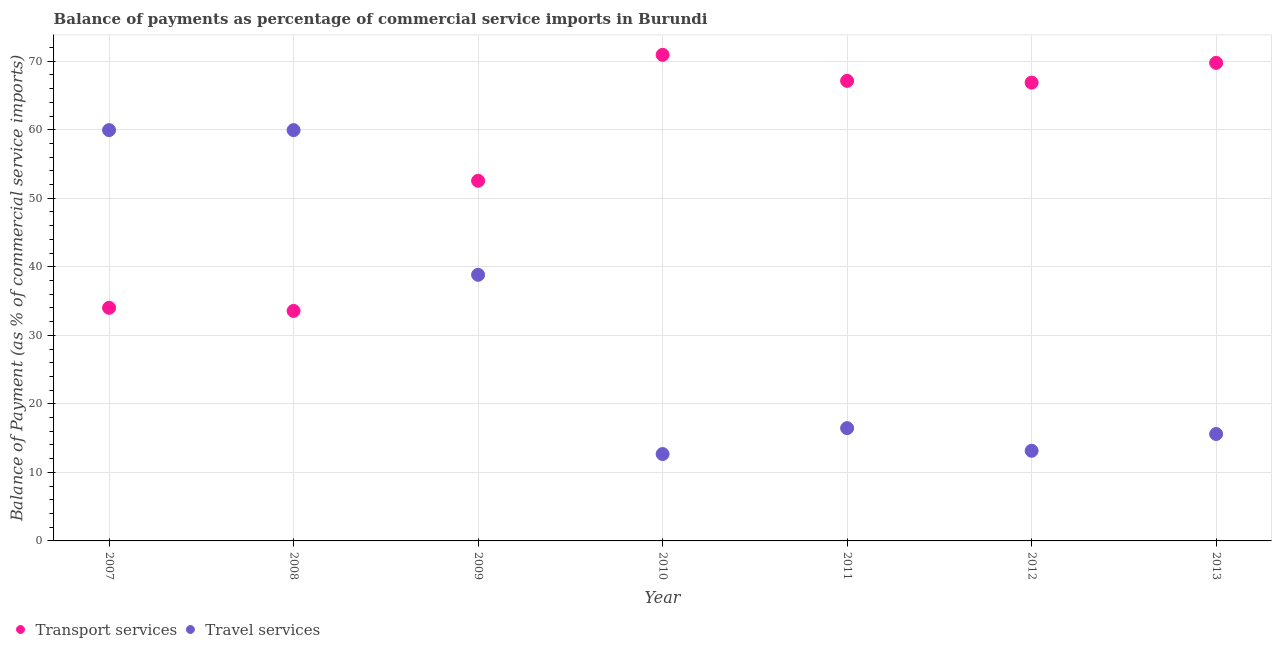How many different coloured dotlines are there?
Your response must be concise. 2. Is the number of dotlines equal to the number of legend labels?
Your answer should be compact. Yes. What is the balance of payments of transport services in 2013?
Ensure brevity in your answer.  69.76. Across all years, what is the maximum balance of payments of travel services?
Keep it short and to the point. 59.95. Across all years, what is the minimum balance of payments of transport services?
Make the answer very short. 33.56. In which year was the balance of payments of travel services maximum?
Keep it short and to the point. 2007. In which year was the balance of payments of transport services minimum?
Your answer should be very brief. 2008. What is the total balance of payments of travel services in the graph?
Your answer should be compact. 216.62. What is the difference between the balance of payments of travel services in 2007 and that in 2010?
Ensure brevity in your answer.  47.27. What is the difference between the balance of payments of travel services in 2007 and the balance of payments of transport services in 2013?
Give a very brief answer. -9.81. What is the average balance of payments of travel services per year?
Your answer should be compact. 30.95. In the year 2009, what is the difference between the balance of payments of transport services and balance of payments of travel services?
Provide a short and direct response. 13.72. In how many years, is the balance of payments of transport services greater than 8 %?
Make the answer very short. 7. What is the ratio of the balance of payments of travel services in 2007 to that in 2009?
Your answer should be very brief. 1.54. What is the difference between the highest and the second highest balance of payments of transport services?
Give a very brief answer. 1.17. What is the difference between the highest and the lowest balance of payments of transport services?
Keep it short and to the point. 37.37. Is the balance of payments of transport services strictly greater than the balance of payments of travel services over the years?
Ensure brevity in your answer.  No. How many years are there in the graph?
Provide a succinct answer. 7. Does the graph contain any zero values?
Give a very brief answer. No. What is the title of the graph?
Offer a very short reply. Balance of payments as percentage of commercial service imports in Burundi. What is the label or title of the Y-axis?
Offer a terse response. Balance of Payment (as % of commercial service imports). What is the Balance of Payment (as % of commercial service imports) in Transport services in 2007?
Offer a terse response. 34.02. What is the Balance of Payment (as % of commercial service imports) of Travel services in 2007?
Make the answer very short. 59.95. What is the Balance of Payment (as % of commercial service imports) in Transport services in 2008?
Offer a terse response. 33.56. What is the Balance of Payment (as % of commercial service imports) of Travel services in 2008?
Ensure brevity in your answer.  59.94. What is the Balance of Payment (as % of commercial service imports) in Transport services in 2009?
Offer a terse response. 52.56. What is the Balance of Payment (as % of commercial service imports) of Travel services in 2009?
Keep it short and to the point. 38.83. What is the Balance of Payment (as % of commercial service imports) in Transport services in 2010?
Give a very brief answer. 70.93. What is the Balance of Payment (as % of commercial service imports) of Travel services in 2010?
Offer a very short reply. 12.68. What is the Balance of Payment (as % of commercial service imports) in Transport services in 2011?
Provide a succinct answer. 67.13. What is the Balance of Payment (as % of commercial service imports) in Travel services in 2011?
Provide a short and direct response. 16.46. What is the Balance of Payment (as % of commercial service imports) in Transport services in 2012?
Make the answer very short. 66.88. What is the Balance of Payment (as % of commercial service imports) in Travel services in 2012?
Offer a very short reply. 13.16. What is the Balance of Payment (as % of commercial service imports) of Transport services in 2013?
Offer a very short reply. 69.76. What is the Balance of Payment (as % of commercial service imports) of Travel services in 2013?
Give a very brief answer. 15.6. Across all years, what is the maximum Balance of Payment (as % of commercial service imports) of Transport services?
Keep it short and to the point. 70.93. Across all years, what is the maximum Balance of Payment (as % of commercial service imports) in Travel services?
Offer a very short reply. 59.95. Across all years, what is the minimum Balance of Payment (as % of commercial service imports) in Transport services?
Make the answer very short. 33.56. Across all years, what is the minimum Balance of Payment (as % of commercial service imports) in Travel services?
Your answer should be very brief. 12.68. What is the total Balance of Payment (as % of commercial service imports) in Transport services in the graph?
Give a very brief answer. 394.84. What is the total Balance of Payment (as % of commercial service imports) in Travel services in the graph?
Provide a short and direct response. 216.62. What is the difference between the Balance of Payment (as % of commercial service imports) in Transport services in 2007 and that in 2008?
Provide a succinct answer. 0.46. What is the difference between the Balance of Payment (as % of commercial service imports) in Travel services in 2007 and that in 2008?
Provide a short and direct response. 0. What is the difference between the Balance of Payment (as % of commercial service imports) in Transport services in 2007 and that in 2009?
Offer a terse response. -18.54. What is the difference between the Balance of Payment (as % of commercial service imports) of Travel services in 2007 and that in 2009?
Provide a short and direct response. 21.11. What is the difference between the Balance of Payment (as % of commercial service imports) in Transport services in 2007 and that in 2010?
Make the answer very short. -36.91. What is the difference between the Balance of Payment (as % of commercial service imports) in Travel services in 2007 and that in 2010?
Your answer should be compact. 47.27. What is the difference between the Balance of Payment (as % of commercial service imports) of Transport services in 2007 and that in 2011?
Provide a succinct answer. -33.11. What is the difference between the Balance of Payment (as % of commercial service imports) in Travel services in 2007 and that in 2011?
Your answer should be very brief. 43.49. What is the difference between the Balance of Payment (as % of commercial service imports) in Transport services in 2007 and that in 2012?
Keep it short and to the point. -32.86. What is the difference between the Balance of Payment (as % of commercial service imports) of Travel services in 2007 and that in 2012?
Your answer should be compact. 46.79. What is the difference between the Balance of Payment (as % of commercial service imports) of Transport services in 2007 and that in 2013?
Make the answer very short. -35.74. What is the difference between the Balance of Payment (as % of commercial service imports) of Travel services in 2007 and that in 2013?
Your answer should be compact. 44.34. What is the difference between the Balance of Payment (as % of commercial service imports) in Transport services in 2008 and that in 2009?
Offer a very short reply. -18.99. What is the difference between the Balance of Payment (as % of commercial service imports) in Travel services in 2008 and that in 2009?
Keep it short and to the point. 21.11. What is the difference between the Balance of Payment (as % of commercial service imports) in Transport services in 2008 and that in 2010?
Keep it short and to the point. -37.37. What is the difference between the Balance of Payment (as % of commercial service imports) of Travel services in 2008 and that in 2010?
Give a very brief answer. 47.27. What is the difference between the Balance of Payment (as % of commercial service imports) in Transport services in 2008 and that in 2011?
Offer a very short reply. -33.57. What is the difference between the Balance of Payment (as % of commercial service imports) in Travel services in 2008 and that in 2011?
Make the answer very short. 43.49. What is the difference between the Balance of Payment (as % of commercial service imports) of Transport services in 2008 and that in 2012?
Your answer should be very brief. -33.32. What is the difference between the Balance of Payment (as % of commercial service imports) in Travel services in 2008 and that in 2012?
Your response must be concise. 46.79. What is the difference between the Balance of Payment (as % of commercial service imports) of Transport services in 2008 and that in 2013?
Give a very brief answer. -36.2. What is the difference between the Balance of Payment (as % of commercial service imports) in Travel services in 2008 and that in 2013?
Provide a short and direct response. 44.34. What is the difference between the Balance of Payment (as % of commercial service imports) in Transport services in 2009 and that in 2010?
Your response must be concise. -18.38. What is the difference between the Balance of Payment (as % of commercial service imports) in Travel services in 2009 and that in 2010?
Your answer should be very brief. 26.16. What is the difference between the Balance of Payment (as % of commercial service imports) in Transport services in 2009 and that in 2011?
Provide a succinct answer. -14.58. What is the difference between the Balance of Payment (as % of commercial service imports) of Travel services in 2009 and that in 2011?
Make the answer very short. 22.37. What is the difference between the Balance of Payment (as % of commercial service imports) in Transport services in 2009 and that in 2012?
Your answer should be very brief. -14.32. What is the difference between the Balance of Payment (as % of commercial service imports) in Travel services in 2009 and that in 2012?
Provide a succinct answer. 25.68. What is the difference between the Balance of Payment (as % of commercial service imports) of Transport services in 2009 and that in 2013?
Your response must be concise. -17.21. What is the difference between the Balance of Payment (as % of commercial service imports) in Travel services in 2009 and that in 2013?
Provide a succinct answer. 23.23. What is the difference between the Balance of Payment (as % of commercial service imports) of Transport services in 2010 and that in 2011?
Your answer should be very brief. 3.8. What is the difference between the Balance of Payment (as % of commercial service imports) of Travel services in 2010 and that in 2011?
Offer a terse response. -3.78. What is the difference between the Balance of Payment (as % of commercial service imports) of Transport services in 2010 and that in 2012?
Ensure brevity in your answer.  4.05. What is the difference between the Balance of Payment (as % of commercial service imports) of Travel services in 2010 and that in 2012?
Your answer should be compact. -0.48. What is the difference between the Balance of Payment (as % of commercial service imports) of Transport services in 2010 and that in 2013?
Your answer should be very brief. 1.17. What is the difference between the Balance of Payment (as % of commercial service imports) in Travel services in 2010 and that in 2013?
Your response must be concise. -2.92. What is the difference between the Balance of Payment (as % of commercial service imports) of Transport services in 2011 and that in 2012?
Make the answer very short. 0.25. What is the difference between the Balance of Payment (as % of commercial service imports) of Travel services in 2011 and that in 2012?
Offer a very short reply. 3.3. What is the difference between the Balance of Payment (as % of commercial service imports) of Transport services in 2011 and that in 2013?
Provide a short and direct response. -2.63. What is the difference between the Balance of Payment (as % of commercial service imports) in Travel services in 2011 and that in 2013?
Keep it short and to the point. 0.86. What is the difference between the Balance of Payment (as % of commercial service imports) of Transport services in 2012 and that in 2013?
Ensure brevity in your answer.  -2.88. What is the difference between the Balance of Payment (as % of commercial service imports) in Travel services in 2012 and that in 2013?
Give a very brief answer. -2.45. What is the difference between the Balance of Payment (as % of commercial service imports) in Transport services in 2007 and the Balance of Payment (as % of commercial service imports) in Travel services in 2008?
Provide a short and direct response. -25.93. What is the difference between the Balance of Payment (as % of commercial service imports) of Transport services in 2007 and the Balance of Payment (as % of commercial service imports) of Travel services in 2009?
Make the answer very short. -4.82. What is the difference between the Balance of Payment (as % of commercial service imports) in Transport services in 2007 and the Balance of Payment (as % of commercial service imports) in Travel services in 2010?
Keep it short and to the point. 21.34. What is the difference between the Balance of Payment (as % of commercial service imports) of Transport services in 2007 and the Balance of Payment (as % of commercial service imports) of Travel services in 2011?
Your response must be concise. 17.56. What is the difference between the Balance of Payment (as % of commercial service imports) in Transport services in 2007 and the Balance of Payment (as % of commercial service imports) in Travel services in 2012?
Your response must be concise. 20.86. What is the difference between the Balance of Payment (as % of commercial service imports) of Transport services in 2007 and the Balance of Payment (as % of commercial service imports) of Travel services in 2013?
Make the answer very short. 18.42. What is the difference between the Balance of Payment (as % of commercial service imports) of Transport services in 2008 and the Balance of Payment (as % of commercial service imports) of Travel services in 2009?
Make the answer very short. -5.27. What is the difference between the Balance of Payment (as % of commercial service imports) in Transport services in 2008 and the Balance of Payment (as % of commercial service imports) in Travel services in 2010?
Provide a short and direct response. 20.88. What is the difference between the Balance of Payment (as % of commercial service imports) of Transport services in 2008 and the Balance of Payment (as % of commercial service imports) of Travel services in 2011?
Provide a succinct answer. 17.1. What is the difference between the Balance of Payment (as % of commercial service imports) of Transport services in 2008 and the Balance of Payment (as % of commercial service imports) of Travel services in 2012?
Provide a succinct answer. 20.41. What is the difference between the Balance of Payment (as % of commercial service imports) of Transport services in 2008 and the Balance of Payment (as % of commercial service imports) of Travel services in 2013?
Provide a succinct answer. 17.96. What is the difference between the Balance of Payment (as % of commercial service imports) in Transport services in 2009 and the Balance of Payment (as % of commercial service imports) in Travel services in 2010?
Provide a short and direct response. 39.88. What is the difference between the Balance of Payment (as % of commercial service imports) in Transport services in 2009 and the Balance of Payment (as % of commercial service imports) in Travel services in 2011?
Your answer should be very brief. 36.1. What is the difference between the Balance of Payment (as % of commercial service imports) in Transport services in 2009 and the Balance of Payment (as % of commercial service imports) in Travel services in 2012?
Provide a short and direct response. 39.4. What is the difference between the Balance of Payment (as % of commercial service imports) of Transport services in 2009 and the Balance of Payment (as % of commercial service imports) of Travel services in 2013?
Ensure brevity in your answer.  36.95. What is the difference between the Balance of Payment (as % of commercial service imports) in Transport services in 2010 and the Balance of Payment (as % of commercial service imports) in Travel services in 2011?
Provide a succinct answer. 54.47. What is the difference between the Balance of Payment (as % of commercial service imports) of Transport services in 2010 and the Balance of Payment (as % of commercial service imports) of Travel services in 2012?
Your response must be concise. 57.78. What is the difference between the Balance of Payment (as % of commercial service imports) of Transport services in 2010 and the Balance of Payment (as % of commercial service imports) of Travel services in 2013?
Provide a short and direct response. 55.33. What is the difference between the Balance of Payment (as % of commercial service imports) in Transport services in 2011 and the Balance of Payment (as % of commercial service imports) in Travel services in 2012?
Keep it short and to the point. 53.98. What is the difference between the Balance of Payment (as % of commercial service imports) of Transport services in 2011 and the Balance of Payment (as % of commercial service imports) of Travel services in 2013?
Give a very brief answer. 51.53. What is the difference between the Balance of Payment (as % of commercial service imports) of Transport services in 2012 and the Balance of Payment (as % of commercial service imports) of Travel services in 2013?
Offer a very short reply. 51.28. What is the average Balance of Payment (as % of commercial service imports) of Transport services per year?
Your answer should be very brief. 56.41. What is the average Balance of Payment (as % of commercial service imports) in Travel services per year?
Make the answer very short. 30.95. In the year 2007, what is the difference between the Balance of Payment (as % of commercial service imports) of Transport services and Balance of Payment (as % of commercial service imports) of Travel services?
Your response must be concise. -25.93. In the year 2008, what is the difference between the Balance of Payment (as % of commercial service imports) of Transport services and Balance of Payment (as % of commercial service imports) of Travel services?
Keep it short and to the point. -26.38. In the year 2009, what is the difference between the Balance of Payment (as % of commercial service imports) in Transport services and Balance of Payment (as % of commercial service imports) in Travel services?
Give a very brief answer. 13.72. In the year 2010, what is the difference between the Balance of Payment (as % of commercial service imports) in Transport services and Balance of Payment (as % of commercial service imports) in Travel services?
Make the answer very short. 58.25. In the year 2011, what is the difference between the Balance of Payment (as % of commercial service imports) of Transport services and Balance of Payment (as % of commercial service imports) of Travel services?
Offer a very short reply. 50.67. In the year 2012, what is the difference between the Balance of Payment (as % of commercial service imports) in Transport services and Balance of Payment (as % of commercial service imports) in Travel services?
Your answer should be very brief. 53.72. In the year 2013, what is the difference between the Balance of Payment (as % of commercial service imports) of Transport services and Balance of Payment (as % of commercial service imports) of Travel services?
Give a very brief answer. 54.16. What is the ratio of the Balance of Payment (as % of commercial service imports) in Transport services in 2007 to that in 2008?
Provide a short and direct response. 1.01. What is the ratio of the Balance of Payment (as % of commercial service imports) in Transport services in 2007 to that in 2009?
Provide a short and direct response. 0.65. What is the ratio of the Balance of Payment (as % of commercial service imports) in Travel services in 2007 to that in 2009?
Your answer should be compact. 1.54. What is the ratio of the Balance of Payment (as % of commercial service imports) of Transport services in 2007 to that in 2010?
Make the answer very short. 0.48. What is the ratio of the Balance of Payment (as % of commercial service imports) in Travel services in 2007 to that in 2010?
Your answer should be compact. 4.73. What is the ratio of the Balance of Payment (as % of commercial service imports) of Transport services in 2007 to that in 2011?
Provide a short and direct response. 0.51. What is the ratio of the Balance of Payment (as % of commercial service imports) of Travel services in 2007 to that in 2011?
Keep it short and to the point. 3.64. What is the ratio of the Balance of Payment (as % of commercial service imports) of Transport services in 2007 to that in 2012?
Offer a terse response. 0.51. What is the ratio of the Balance of Payment (as % of commercial service imports) in Travel services in 2007 to that in 2012?
Provide a short and direct response. 4.56. What is the ratio of the Balance of Payment (as % of commercial service imports) of Transport services in 2007 to that in 2013?
Your answer should be very brief. 0.49. What is the ratio of the Balance of Payment (as % of commercial service imports) of Travel services in 2007 to that in 2013?
Ensure brevity in your answer.  3.84. What is the ratio of the Balance of Payment (as % of commercial service imports) in Transport services in 2008 to that in 2009?
Offer a terse response. 0.64. What is the ratio of the Balance of Payment (as % of commercial service imports) in Travel services in 2008 to that in 2009?
Provide a short and direct response. 1.54. What is the ratio of the Balance of Payment (as % of commercial service imports) in Transport services in 2008 to that in 2010?
Keep it short and to the point. 0.47. What is the ratio of the Balance of Payment (as % of commercial service imports) in Travel services in 2008 to that in 2010?
Offer a very short reply. 4.73. What is the ratio of the Balance of Payment (as % of commercial service imports) of Transport services in 2008 to that in 2011?
Provide a succinct answer. 0.5. What is the ratio of the Balance of Payment (as % of commercial service imports) of Travel services in 2008 to that in 2011?
Your response must be concise. 3.64. What is the ratio of the Balance of Payment (as % of commercial service imports) in Transport services in 2008 to that in 2012?
Keep it short and to the point. 0.5. What is the ratio of the Balance of Payment (as % of commercial service imports) in Travel services in 2008 to that in 2012?
Your response must be concise. 4.56. What is the ratio of the Balance of Payment (as % of commercial service imports) of Transport services in 2008 to that in 2013?
Your response must be concise. 0.48. What is the ratio of the Balance of Payment (as % of commercial service imports) of Travel services in 2008 to that in 2013?
Ensure brevity in your answer.  3.84. What is the ratio of the Balance of Payment (as % of commercial service imports) of Transport services in 2009 to that in 2010?
Keep it short and to the point. 0.74. What is the ratio of the Balance of Payment (as % of commercial service imports) of Travel services in 2009 to that in 2010?
Your answer should be compact. 3.06. What is the ratio of the Balance of Payment (as % of commercial service imports) of Transport services in 2009 to that in 2011?
Your answer should be very brief. 0.78. What is the ratio of the Balance of Payment (as % of commercial service imports) in Travel services in 2009 to that in 2011?
Your answer should be compact. 2.36. What is the ratio of the Balance of Payment (as % of commercial service imports) of Transport services in 2009 to that in 2012?
Your answer should be compact. 0.79. What is the ratio of the Balance of Payment (as % of commercial service imports) of Travel services in 2009 to that in 2012?
Your response must be concise. 2.95. What is the ratio of the Balance of Payment (as % of commercial service imports) of Transport services in 2009 to that in 2013?
Offer a terse response. 0.75. What is the ratio of the Balance of Payment (as % of commercial service imports) in Travel services in 2009 to that in 2013?
Offer a very short reply. 2.49. What is the ratio of the Balance of Payment (as % of commercial service imports) in Transport services in 2010 to that in 2011?
Offer a very short reply. 1.06. What is the ratio of the Balance of Payment (as % of commercial service imports) of Travel services in 2010 to that in 2011?
Offer a terse response. 0.77. What is the ratio of the Balance of Payment (as % of commercial service imports) in Transport services in 2010 to that in 2012?
Provide a succinct answer. 1.06. What is the ratio of the Balance of Payment (as % of commercial service imports) of Travel services in 2010 to that in 2012?
Keep it short and to the point. 0.96. What is the ratio of the Balance of Payment (as % of commercial service imports) in Transport services in 2010 to that in 2013?
Provide a succinct answer. 1.02. What is the ratio of the Balance of Payment (as % of commercial service imports) in Travel services in 2010 to that in 2013?
Your answer should be very brief. 0.81. What is the ratio of the Balance of Payment (as % of commercial service imports) of Travel services in 2011 to that in 2012?
Offer a terse response. 1.25. What is the ratio of the Balance of Payment (as % of commercial service imports) of Transport services in 2011 to that in 2013?
Offer a very short reply. 0.96. What is the ratio of the Balance of Payment (as % of commercial service imports) of Travel services in 2011 to that in 2013?
Make the answer very short. 1.05. What is the ratio of the Balance of Payment (as % of commercial service imports) in Transport services in 2012 to that in 2013?
Offer a very short reply. 0.96. What is the ratio of the Balance of Payment (as % of commercial service imports) of Travel services in 2012 to that in 2013?
Offer a very short reply. 0.84. What is the difference between the highest and the second highest Balance of Payment (as % of commercial service imports) in Transport services?
Your answer should be very brief. 1.17. What is the difference between the highest and the second highest Balance of Payment (as % of commercial service imports) of Travel services?
Offer a very short reply. 0. What is the difference between the highest and the lowest Balance of Payment (as % of commercial service imports) in Transport services?
Provide a short and direct response. 37.37. What is the difference between the highest and the lowest Balance of Payment (as % of commercial service imports) in Travel services?
Give a very brief answer. 47.27. 